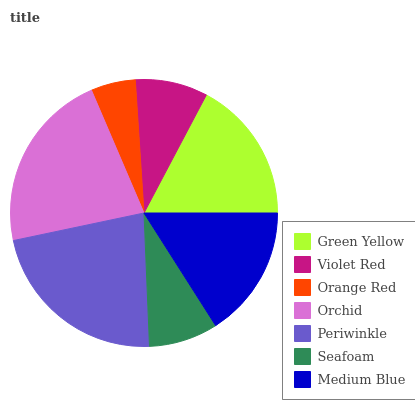Is Orange Red the minimum?
Answer yes or no. Yes. Is Periwinkle the maximum?
Answer yes or no. Yes. Is Violet Red the minimum?
Answer yes or no. No. Is Violet Red the maximum?
Answer yes or no. No. Is Green Yellow greater than Violet Red?
Answer yes or no. Yes. Is Violet Red less than Green Yellow?
Answer yes or no. Yes. Is Violet Red greater than Green Yellow?
Answer yes or no. No. Is Green Yellow less than Violet Red?
Answer yes or no. No. Is Medium Blue the high median?
Answer yes or no. Yes. Is Medium Blue the low median?
Answer yes or no. Yes. Is Violet Red the high median?
Answer yes or no. No. Is Violet Red the low median?
Answer yes or no. No. 